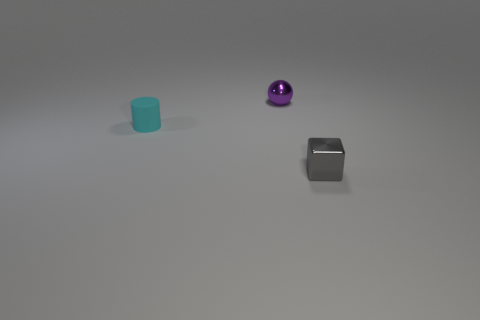The small object that is in front of the cyan cylinder has what shape?
Provide a succinct answer. Cube. What shape is the object that is left of the tiny shiny object that is behind the thing to the left of the small purple metal thing?
Your answer should be very brief. Cylinder. What number of things are brown balls or purple things?
Provide a succinct answer. 1. There is a tiny shiny object that is behind the gray object; is its shape the same as the object in front of the cyan matte object?
Ensure brevity in your answer.  No. How many things are to the right of the small cyan rubber thing and in front of the small metallic sphere?
Your answer should be very brief. 1. What number of other things are there of the same size as the gray object?
Your response must be concise. 2. What is the material of the object that is behind the gray cube and to the right of the small cyan cylinder?
Provide a short and direct response. Metal. There is a thing that is both behind the gray metal object and in front of the purple ball; what shape is it?
Your response must be concise. Cylinder. Do the gray thing and the object that is behind the tiny cyan matte cylinder have the same size?
Ensure brevity in your answer.  Yes. Is the shape of the small purple shiny thing the same as the cyan matte thing?
Your answer should be very brief. No. 